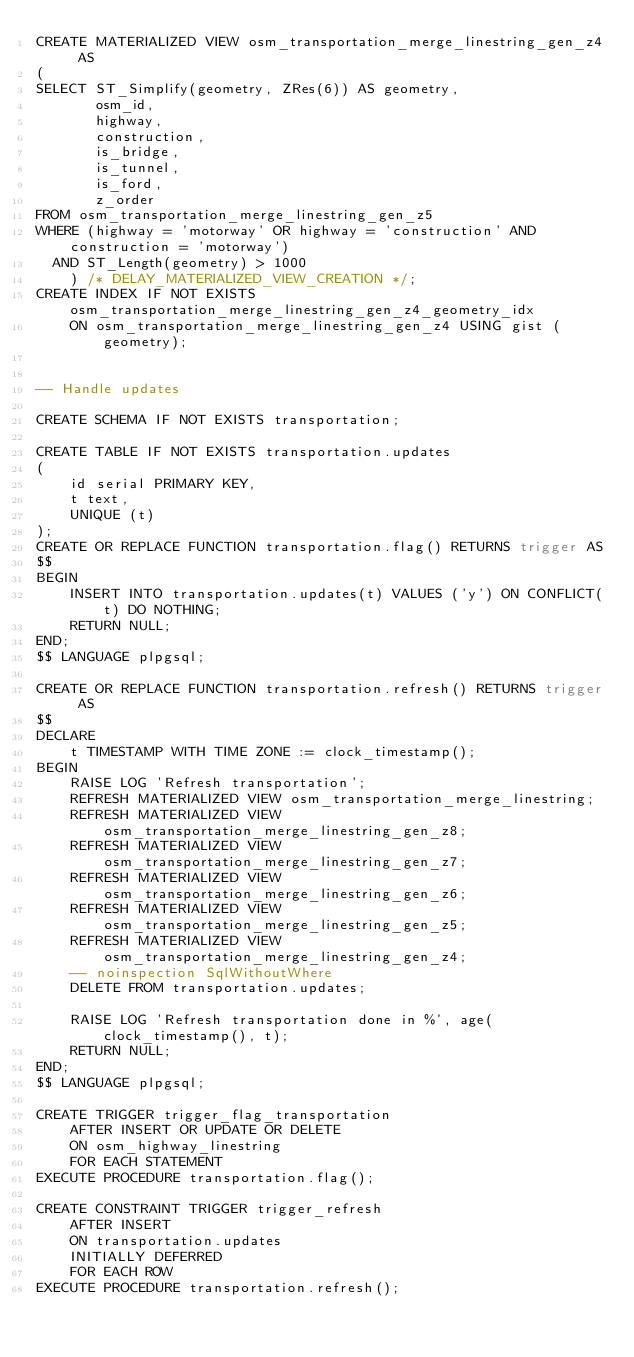Convert code to text. <code><loc_0><loc_0><loc_500><loc_500><_SQL_>CREATE MATERIALIZED VIEW osm_transportation_merge_linestring_gen_z4 AS
(
SELECT ST_Simplify(geometry, ZRes(6)) AS geometry,
       osm_id,
       highway,
       construction,
       is_bridge,
       is_tunnel,
       is_ford,
       z_order
FROM osm_transportation_merge_linestring_gen_z5
WHERE (highway = 'motorway' OR highway = 'construction' AND construction = 'motorway')
  AND ST_Length(geometry) > 1000
    ) /* DELAY_MATERIALIZED_VIEW_CREATION */;
CREATE INDEX IF NOT EXISTS osm_transportation_merge_linestring_gen_z4_geometry_idx
    ON osm_transportation_merge_linestring_gen_z4 USING gist (geometry);


-- Handle updates

CREATE SCHEMA IF NOT EXISTS transportation;

CREATE TABLE IF NOT EXISTS transportation.updates
(
    id serial PRIMARY KEY,
    t text,
    UNIQUE (t)
);
CREATE OR REPLACE FUNCTION transportation.flag() RETURNS trigger AS
$$
BEGIN
    INSERT INTO transportation.updates(t) VALUES ('y') ON CONFLICT(t) DO NOTHING;
    RETURN NULL;
END;
$$ LANGUAGE plpgsql;

CREATE OR REPLACE FUNCTION transportation.refresh() RETURNS trigger AS
$$
DECLARE
    t TIMESTAMP WITH TIME ZONE := clock_timestamp();
BEGIN
    RAISE LOG 'Refresh transportation';
    REFRESH MATERIALIZED VIEW osm_transportation_merge_linestring;
    REFRESH MATERIALIZED VIEW osm_transportation_merge_linestring_gen_z8;
    REFRESH MATERIALIZED VIEW osm_transportation_merge_linestring_gen_z7;
    REFRESH MATERIALIZED VIEW osm_transportation_merge_linestring_gen_z6;
    REFRESH MATERIALIZED VIEW osm_transportation_merge_linestring_gen_z5;
    REFRESH MATERIALIZED VIEW osm_transportation_merge_linestring_gen_z4;
    -- noinspection SqlWithoutWhere
    DELETE FROM transportation.updates;

    RAISE LOG 'Refresh transportation done in %', age(clock_timestamp(), t);
    RETURN NULL;
END;
$$ LANGUAGE plpgsql;

CREATE TRIGGER trigger_flag_transportation
    AFTER INSERT OR UPDATE OR DELETE
    ON osm_highway_linestring
    FOR EACH STATEMENT
EXECUTE PROCEDURE transportation.flag();

CREATE CONSTRAINT TRIGGER trigger_refresh
    AFTER INSERT
    ON transportation.updates
    INITIALLY DEFERRED
    FOR EACH ROW
EXECUTE PROCEDURE transportation.refresh();</code> 